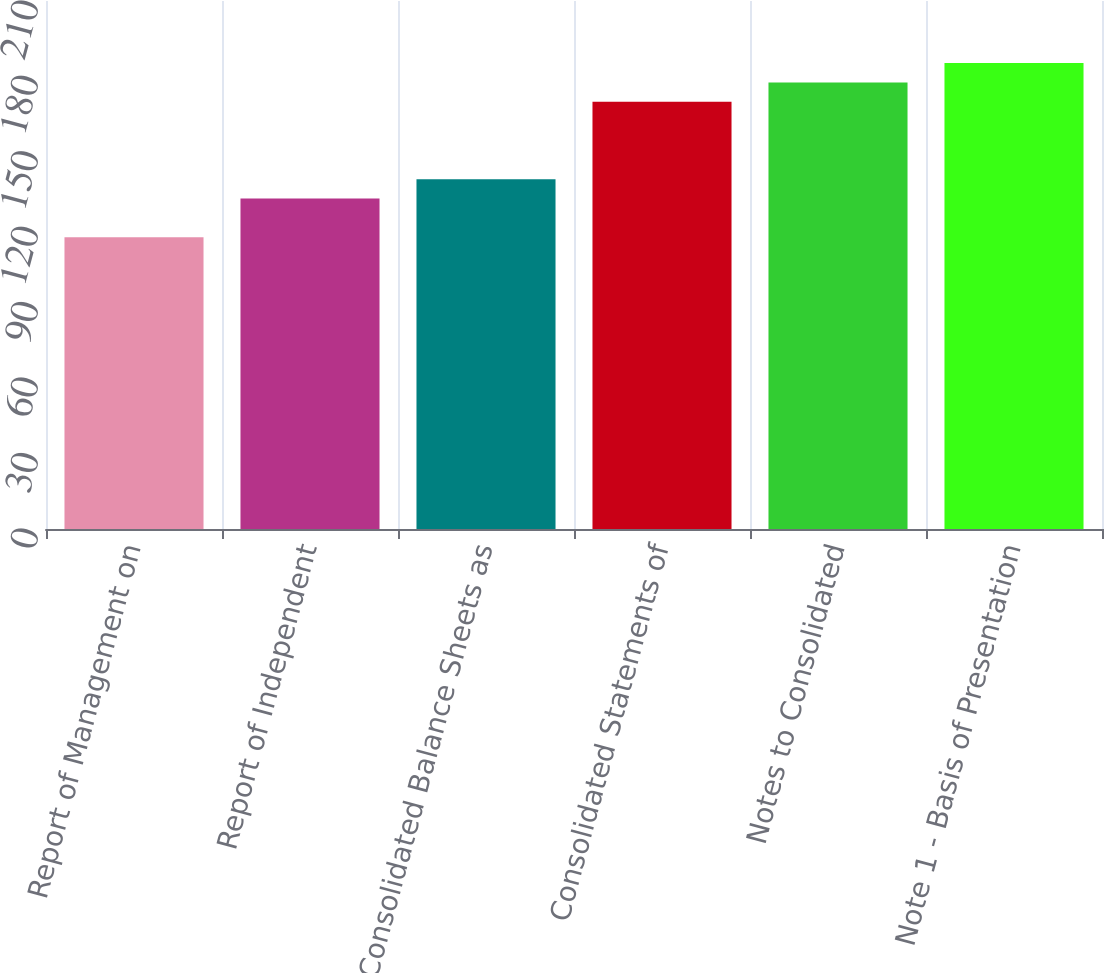Convert chart. <chart><loc_0><loc_0><loc_500><loc_500><bar_chart><fcel>Report of Management on<fcel>Report of Independent<fcel>Consolidated Balance Sheets as<fcel>Consolidated Statements of<fcel>Notes to Consolidated<fcel>Note 1 - Basis of Presentation<nl><fcel>116<fcel>131.4<fcel>139.1<fcel>169.9<fcel>177.6<fcel>185.3<nl></chart> 